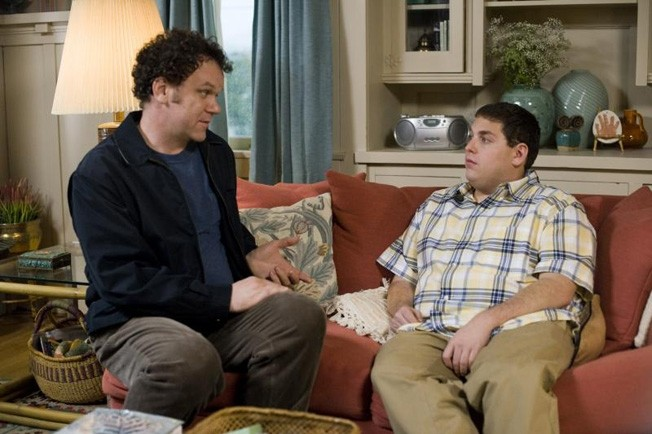Can you give a deeper insight into how the director could be using the actors' positioning to enhance the story? The director strategically positions Jonah Hill on the arm of the couch, slightly above John C. Reilly who is seated. This could symbolize Jonah's character's desire for dominance or elevation in the conversation, while still maintaining a closeness indicative of their personal relationship. It subtly reflects the power dynamics at play and adds layers to their interaction, suggesting an underlying struggle for control or understanding within their relationship. What does the mise-en-scène tell us about the characters' personalities or life situations? The setting is cluttered with personal items and homely decorations, which suggest that these characters inhabit a very personal space shared with family or close acquaintances. The choice of a red couch and soft decorative elements like cushions and lamps indicate a comfortable, lived-in space, reflecting aspects of their personalities that value comfort, familiarity, and perhaps a resistance to change. This scene's detailed mise-en-scène subtly complements the complexity of their discussions and the intimate nature of their relationship. 